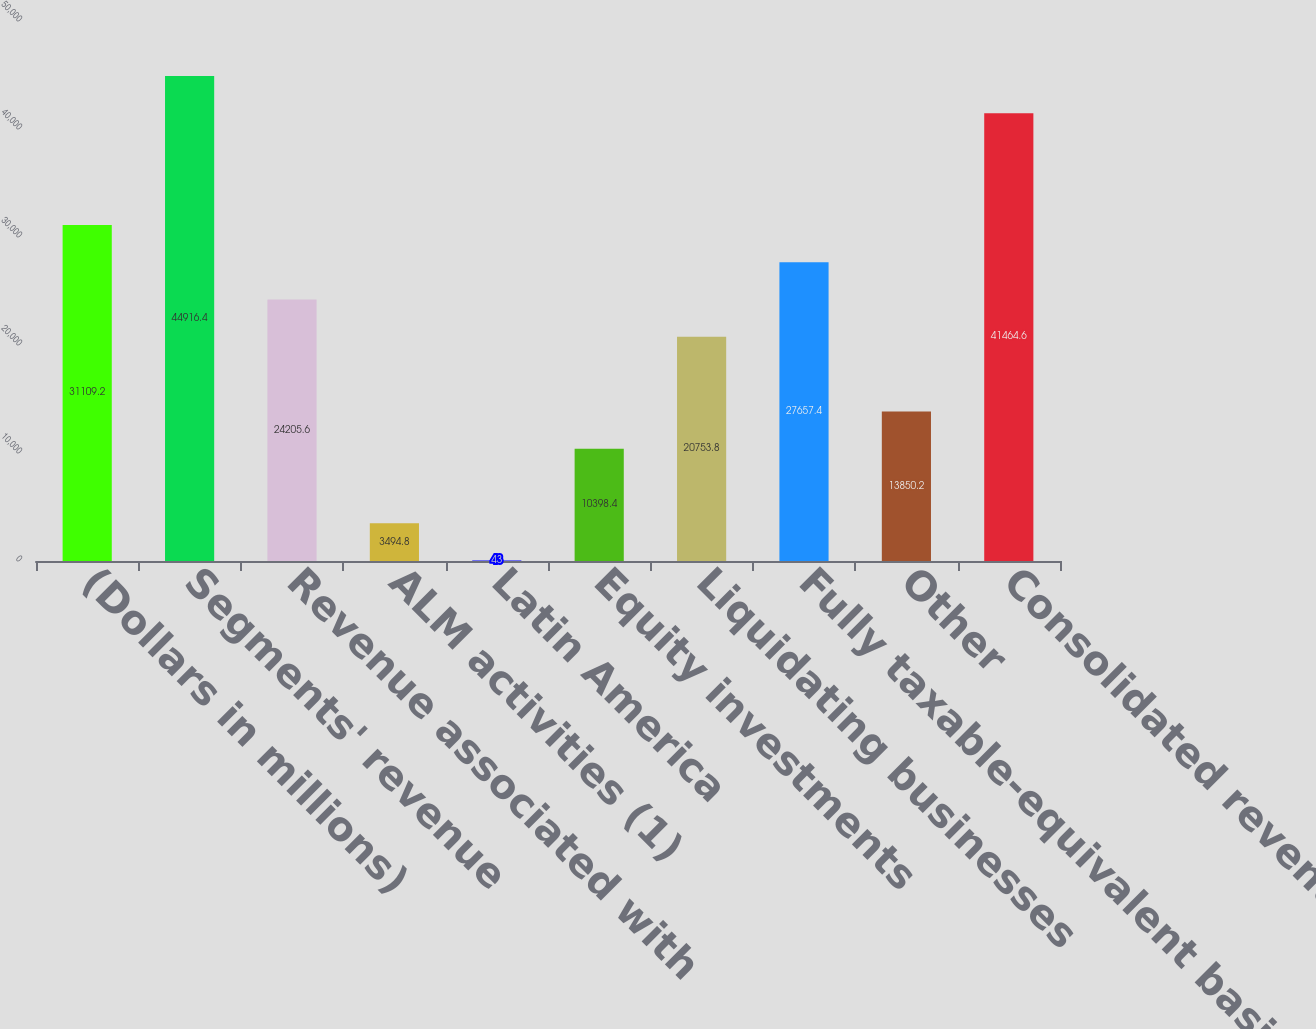<chart> <loc_0><loc_0><loc_500><loc_500><bar_chart><fcel>(Dollars in millions)<fcel>Segments' revenue<fcel>Revenue associated with<fcel>ALM activities (1)<fcel>Latin America<fcel>Equity investments<fcel>Liquidating businesses<fcel>Fully taxable-equivalent basis<fcel>Other<fcel>Consolidated revenue<nl><fcel>31109.2<fcel>44916.4<fcel>24205.6<fcel>3494.8<fcel>43<fcel>10398.4<fcel>20753.8<fcel>27657.4<fcel>13850.2<fcel>41464.6<nl></chart> 